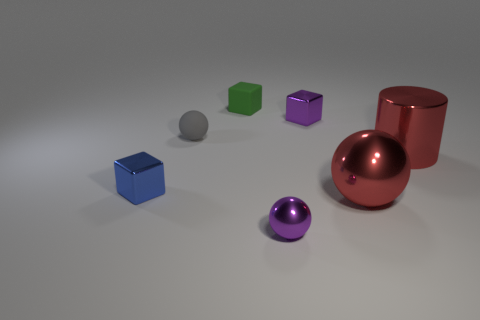There is a rubber thing in front of the green cube; is its shape the same as the tiny green thing?
Make the answer very short. No. Is the number of gray rubber spheres that are in front of the blue block greater than the number of tiny purple metal spheres?
Provide a succinct answer. No. There is a ball that is on the left side of the purple thing in front of the red sphere; what is its color?
Your answer should be very brief. Gray. How many tiny purple metal cubes are there?
Your response must be concise. 1. How many things are both behind the purple cube and to the left of the gray sphere?
Ensure brevity in your answer.  0. Is there any other thing that is the same shape as the gray matte thing?
Provide a short and direct response. Yes. There is a cylinder; is it the same color as the metallic block in front of the purple block?
Your response must be concise. No. There is a tiny purple metallic object that is in front of the blue block; what shape is it?
Your answer should be compact. Sphere. What number of other things are there of the same material as the big red cylinder
Offer a terse response. 4. What is the material of the blue object?
Your answer should be compact. Metal. 